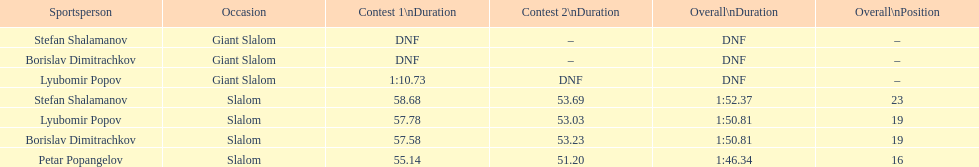How many athletes are there total? 4. 